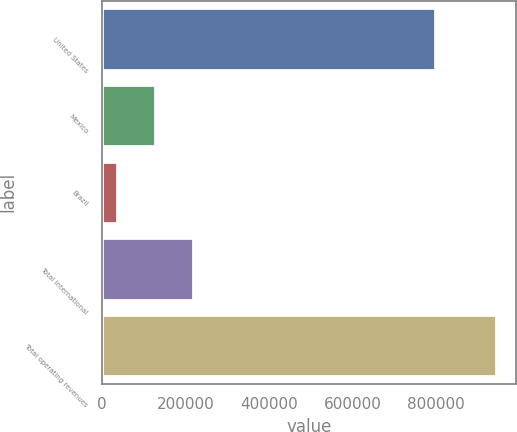Convert chart. <chart><loc_0><loc_0><loc_500><loc_500><bar_chart><fcel>United States<fcel>Mexico<fcel>Brazil<fcel>Total International<fcel>Total operating revenues<nl><fcel>798010<fcel>126298<fcel>35355<fcel>217241<fcel>944786<nl></chart> 